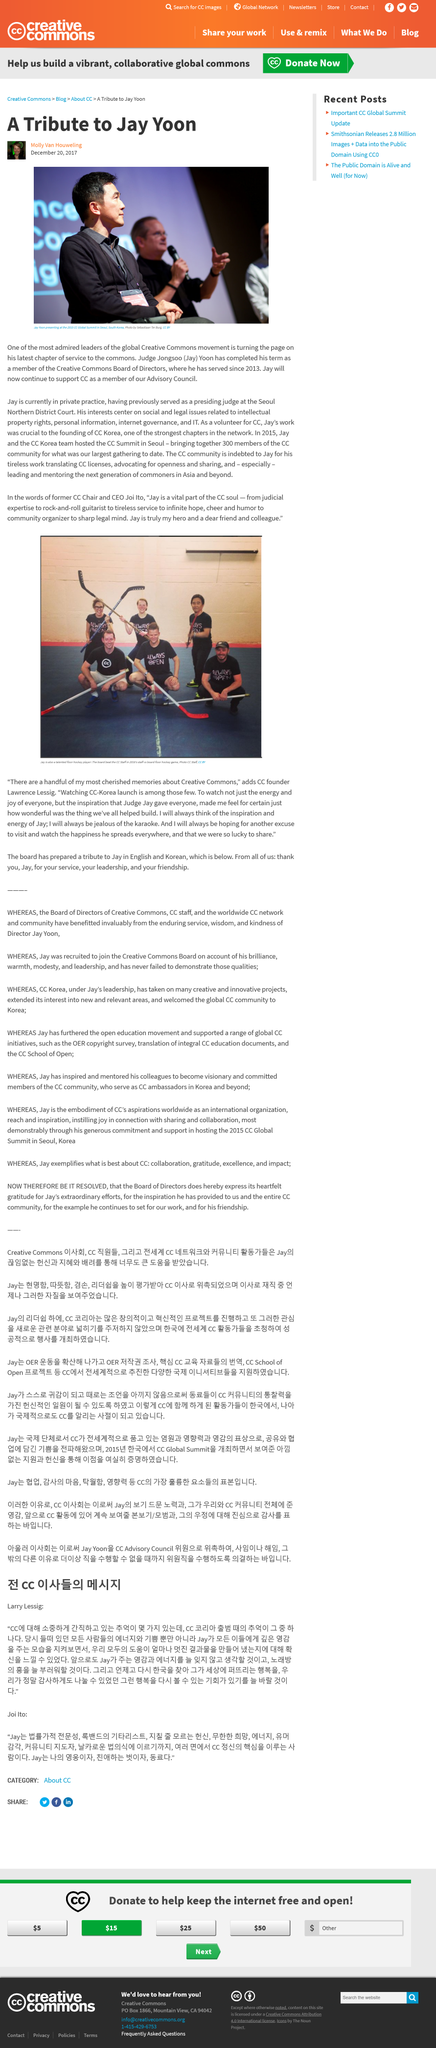Give some essential details in this illustration. Jay Yoon was a judge by profession. Jay Yoon was a judge at the Seoul Northern District Court. 300 members gathered at the CC Summit. 